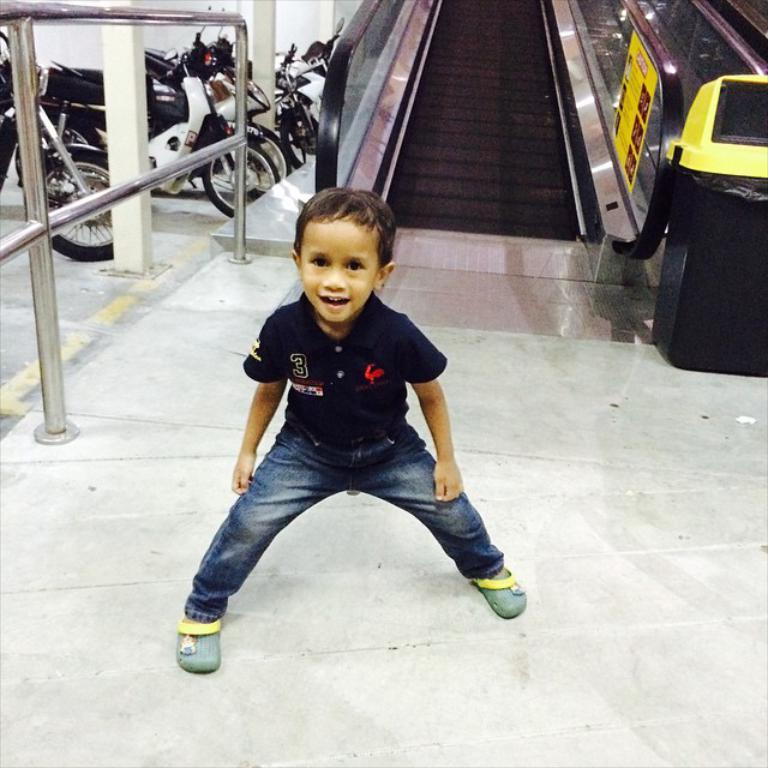What is the main subject of the image? The main subject of the image is a kid. What is the kid wearing? The kid is wearing a black T-shirt and blue jeans. What is the kid's posture in the image? The kid is standing. What can be seen in the background of the image? There is an escalator, vehicles parked, and fencing in the background of the image. What type of pen is the kid holding in the image? There is no pen present in the image; the kid is not holding any writing instrument. 